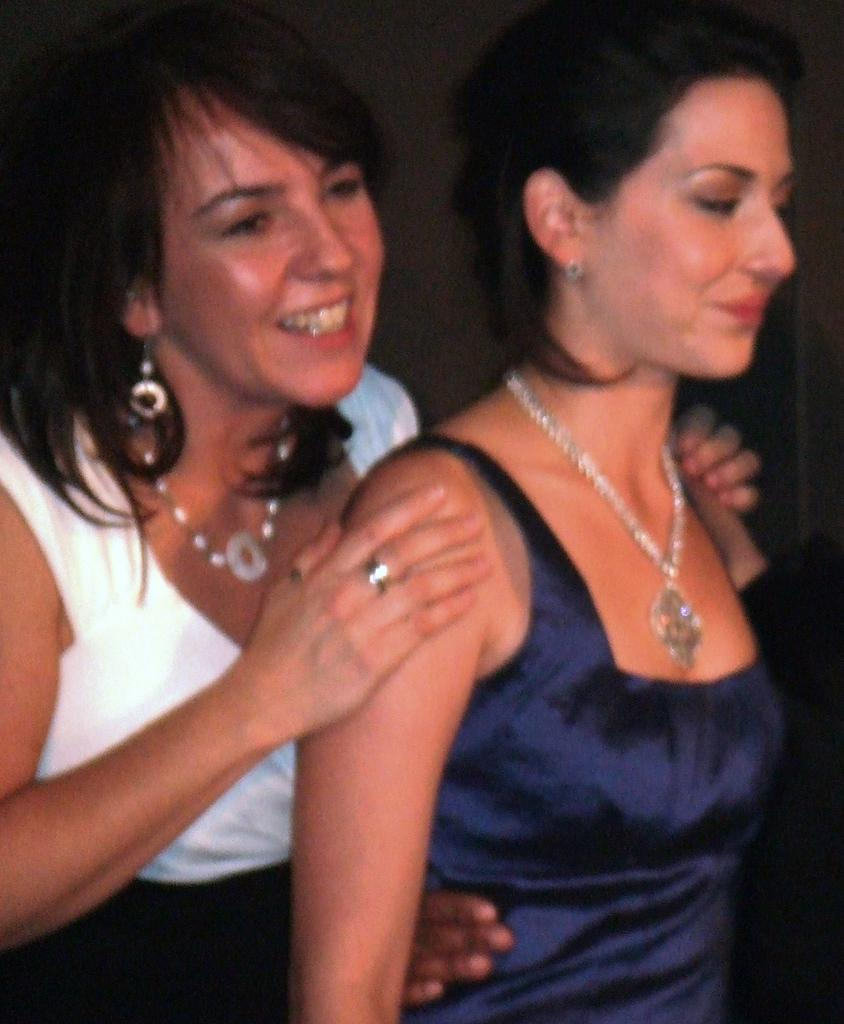How many people are in the image? There are two ladies in the image. What are the ladies doing in the image? The ladies are standing. What can be observed about the background of the image? The background of the image is dark. What type of crow is perched on the shape in the image? There is no crow or shape present in the image. How does the heat affect the ladies in the image? The provided facts do not mention anything about heat, so we cannot determine its effect on the ladies in the image. 